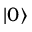<formula> <loc_0><loc_0><loc_500><loc_500>| 0 \rangle</formula> 